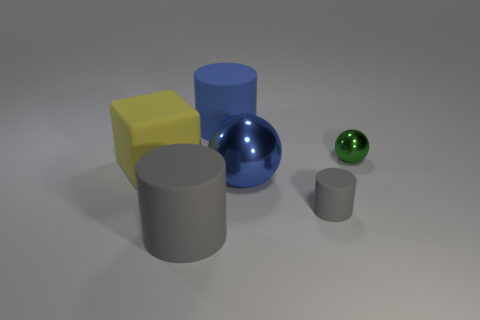Subtract all big blue cylinders. How many cylinders are left? 2 Subtract all gray cylinders. How many cylinders are left? 1 Subtract all spheres. How many objects are left? 4 Subtract all red balls. How many red cubes are left? 0 Subtract all small gray matte objects. Subtract all small balls. How many objects are left? 4 Add 1 big gray matte cylinders. How many big gray matte cylinders are left? 2 Add 4 large blue things. How many large blue things exist? 6 Add 3 blue metal objects. How many objects exist? 9 Subtract 0 red blocks. How many objects are left? 6 Subtract all yellow cylinders. Subtract all purple blocks. How many cylinders are left? 3 